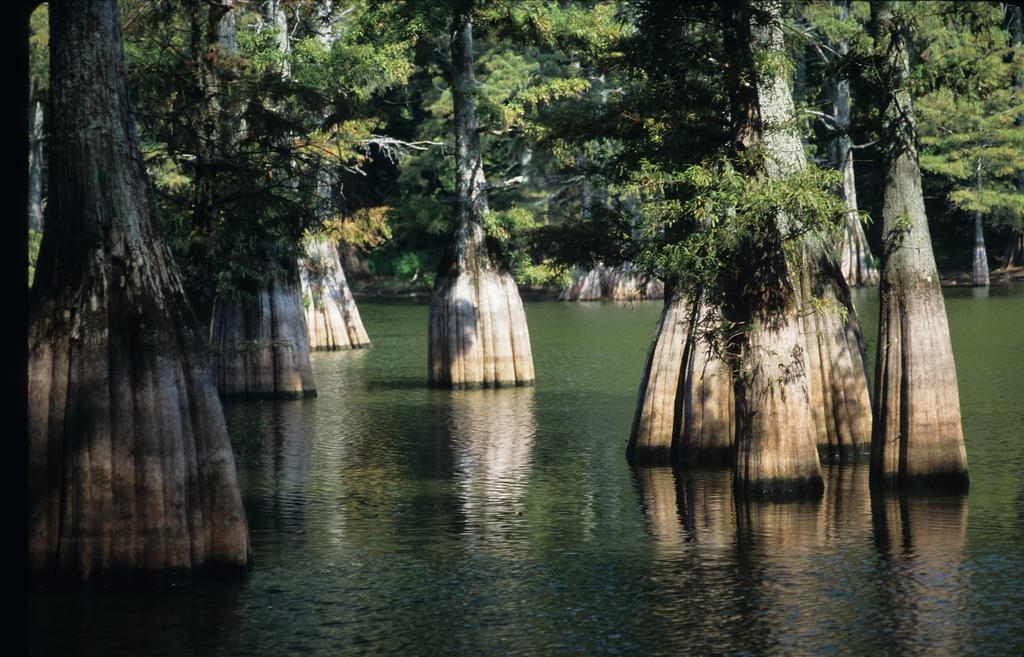Can you describe this image briefly? In this image there is the water. There are trees in the water. The trees have huge trunks. 